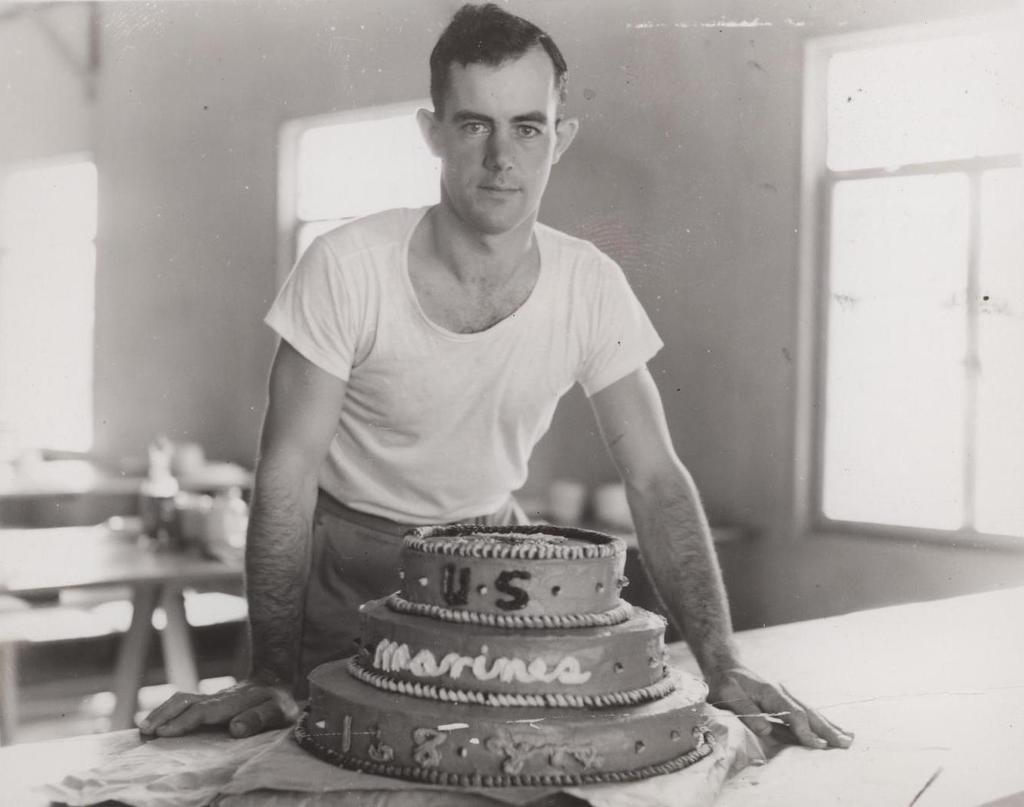What is the man in the image standing in front of? The man is standing in front of a cake. Where is the cake located? The cake is placed on a table. What can be seen in the background of the image? There are tables, windows, and a wall in the background. What type of competition is the man participating in, as seen in the image? There is no indication of a competition in the image; it simply shows a man standing in front of a cake. What is the man carrying in a bag, as seen in the image? There is no bag or any item being carried by the man in the image. 